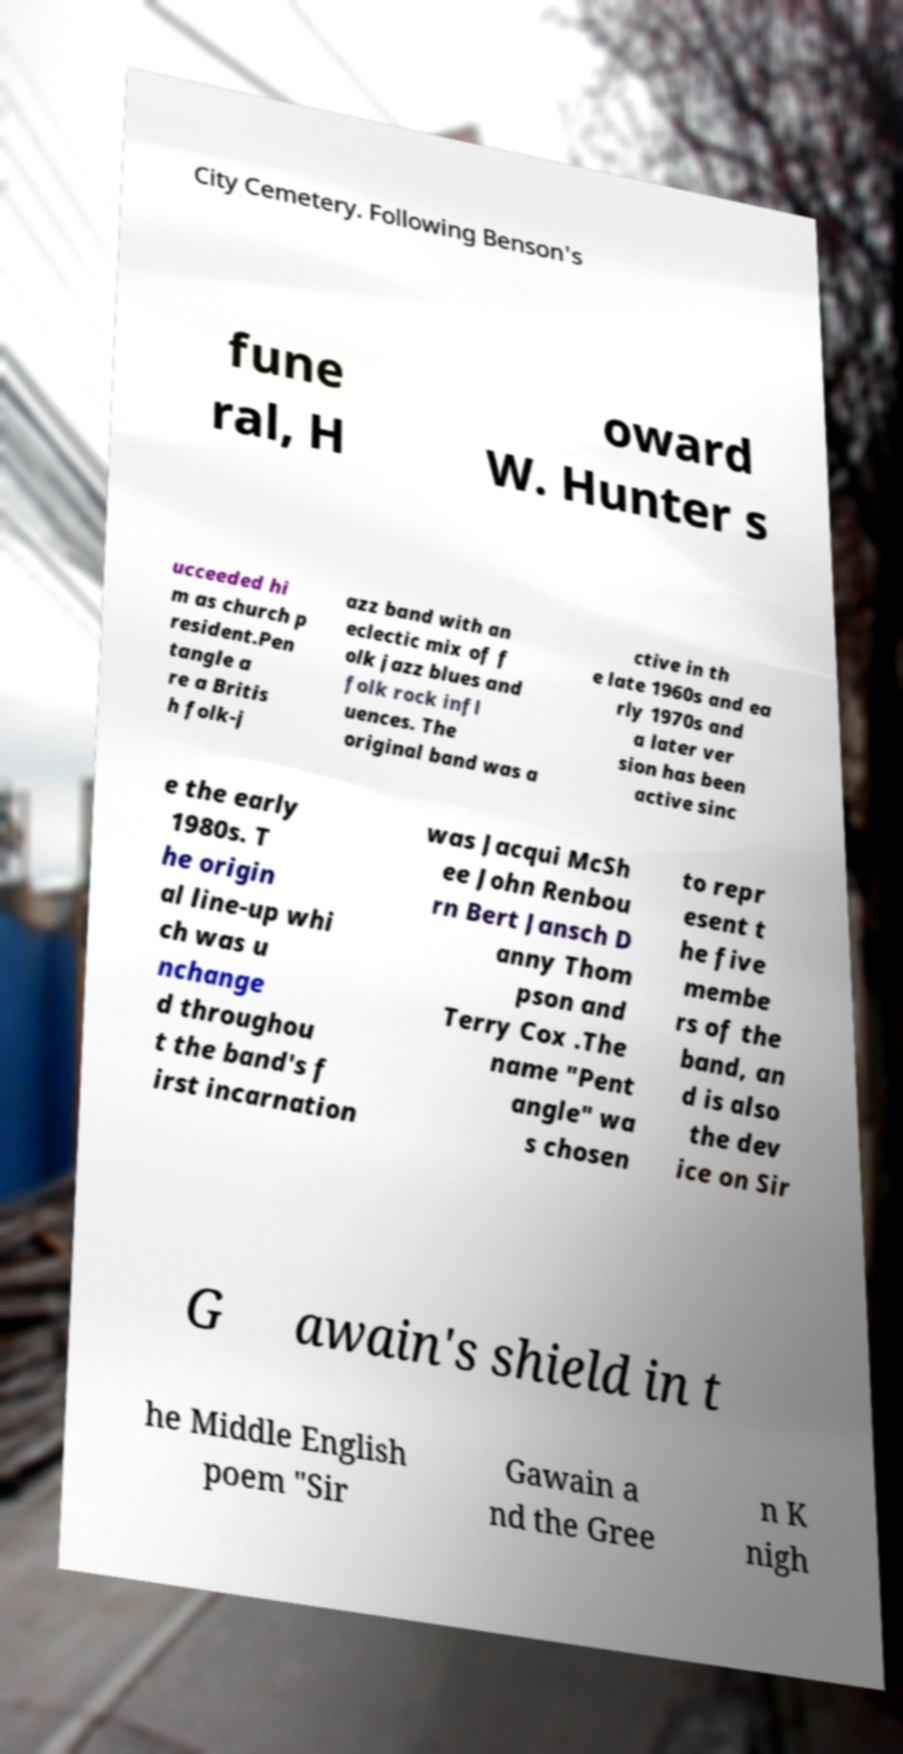Please identify and transcribe the text found in this image. City Cemetery. Following Benson's fune ral, H oward W. Hunter s ucceeded hi m as church p resident.Pen tangle a re a Britis h folk-j azz band with an eclectic mix of f olk jazz blues and folk rock infl uences. The original band was a ctive in th e late 1960s and ea rly 1970s and a later ver sion has been active sinc e the early 1980s. T he origin al line-up whi ch was u nchange d throughou t the band's f irst incarnation was Jacqui McSh ee John Renbou rn Bert Jansch D anny Thom pson and Terry Cox .The name "Pent angle" wa s chosen to repr esent t he five membe rs of the band, an d is also the dev ice on Sir G awain's shield in t he Middle English poem "Sir Gawain a nd the Gree n K nigh 